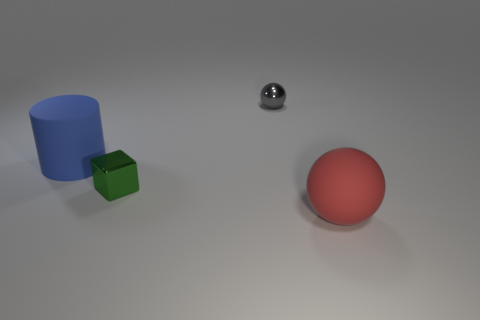How many shiny objects are either red things or small green cylinders? In the image, there are no shiny objects that meet the criteria of being either red things or small green cylinders. However, there is one shiny object, which is a small silver sphere, and a red object, which is a large red sphere. As for small green cylinders, there is one, but it is not shiny. 